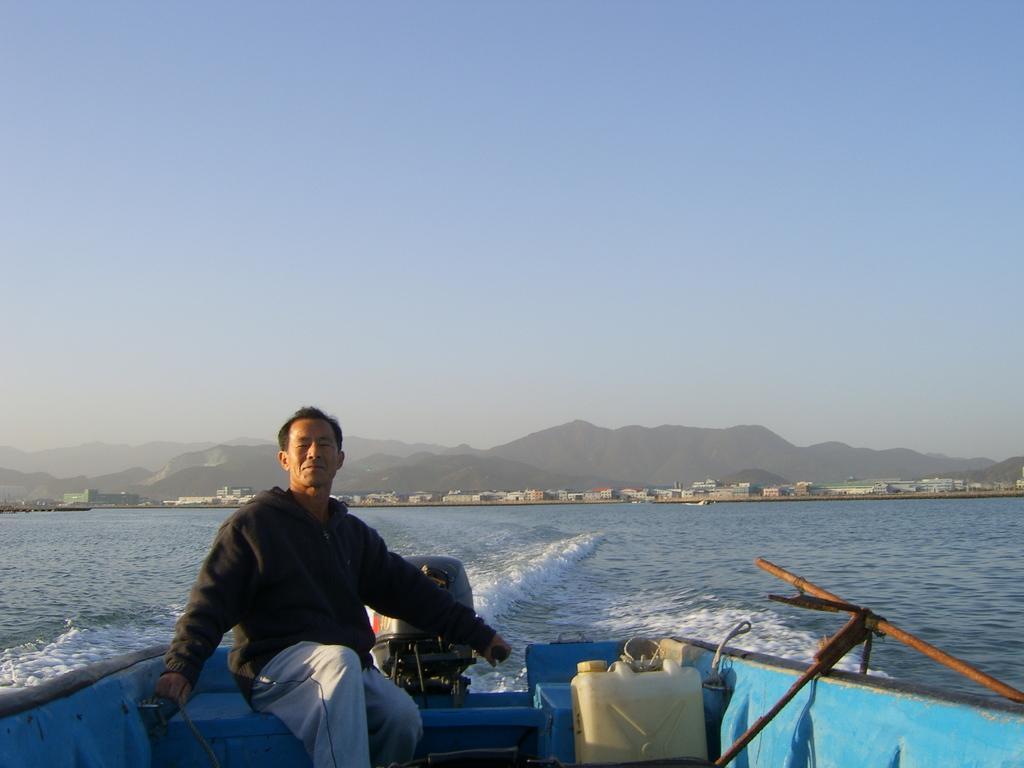Could you give a brief overview of what you see in this image? In the foreground of the picture there is a person riding a boat, in the boat there are some objects. In the center of the picture there is a water body. In the background there are buildings and hills. Sky is sunny. 